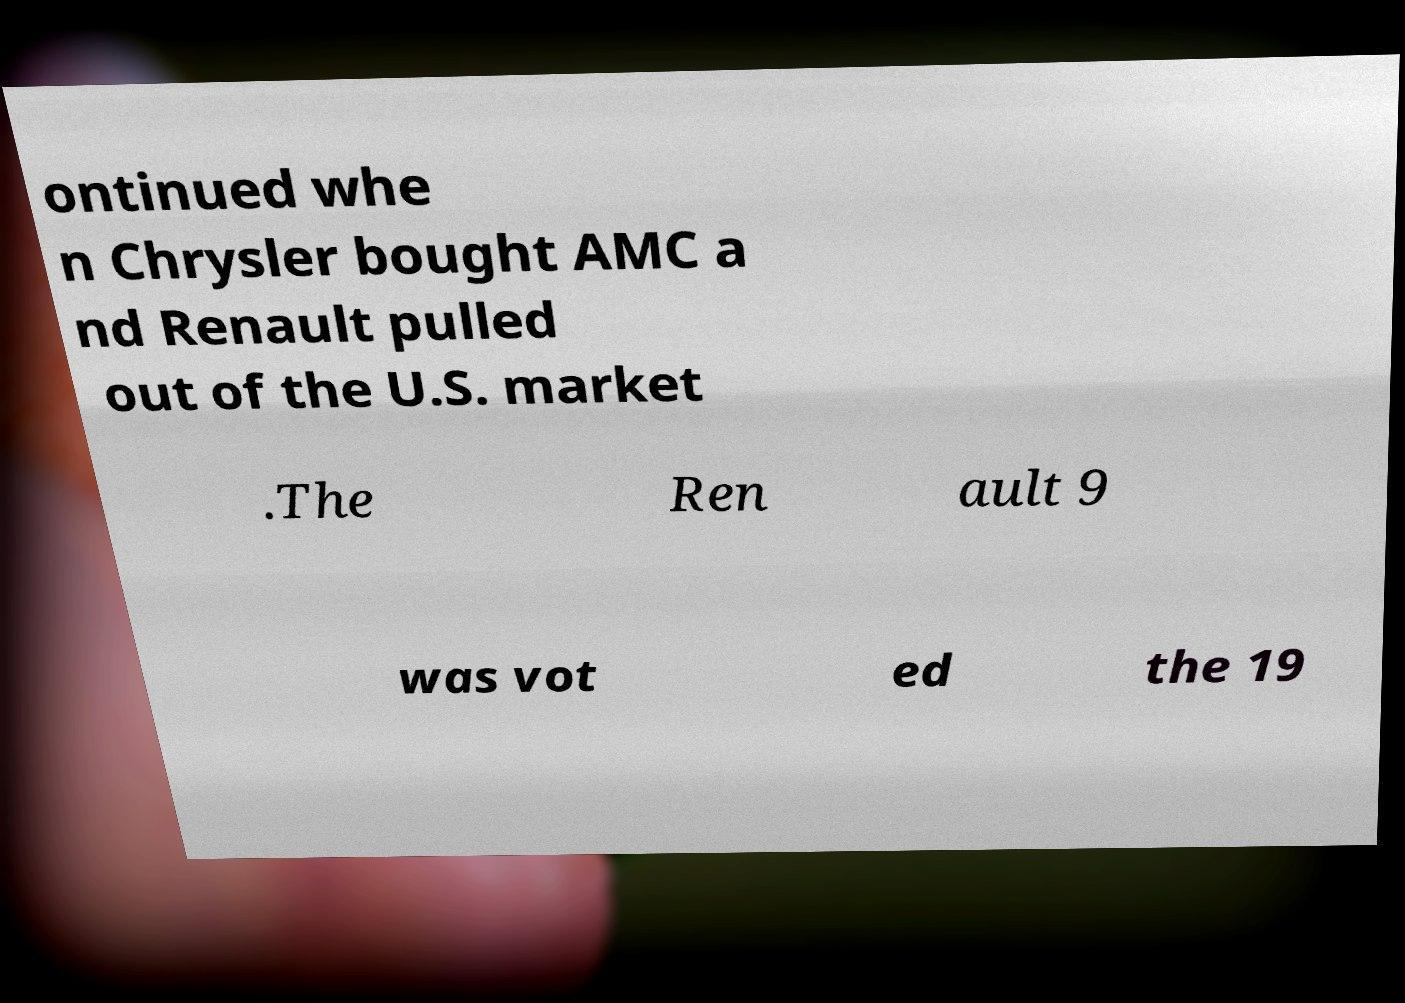Could you extract and type out the text from this image? ontinued whe n Chrysler bought AMC a nd Renault pulled out of the U.S. market .The Ren ault 9 was vot ed the 19 